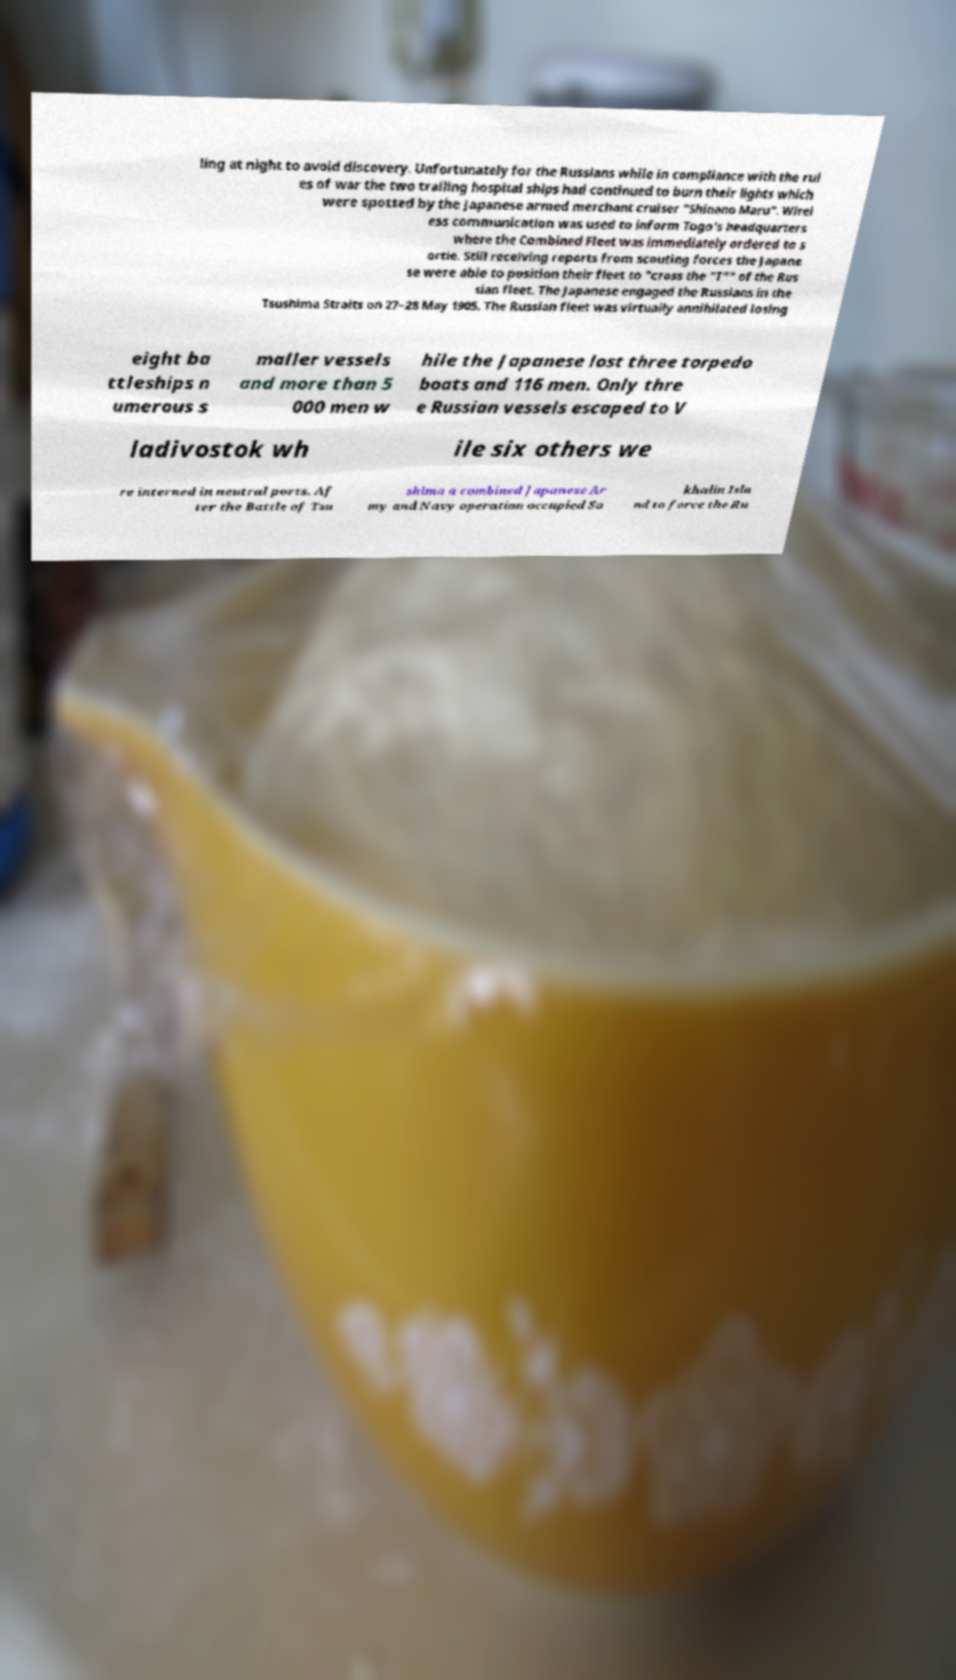There's text embedded in this image that I need extracted. Can you transcribe it verbatim? ling at night to avoid discovery. Unfortunately for the Russians while in compliance with the rul es of war the two trailing hospital ships had continued to burn their lights which were spotted by the Japanese armed merchant cruiser "Shinano Maru". Wirel ess communication was used to inform Togo's headquarters where the Combined Fleet was immediately ordered to s ortie. Still receiving reports from scouting forces the Japane se were able to position their fleet to "cross the "T"" of the Rus sian fleet. The Japanese engaged the Russians in the Tsushima Straits on 27–28 May 1905. The Russian fleet was virtually annihilated losing eight ba ttleships n umerous s maller vessels and more than 5 000 men w hile the Japanese lost three torpedo boats and 116 men. Only thre e Russian vessels escaped to V ladivostok wh ile six others we re interned in neutral ports. Af ter the Battle of Tsu shima a combined Japanese Ar my and Navy operation occupied Sa khalin Isla nd to force the Ru 